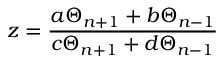<formula> <loc_0><loc_0><loc_500><loc_500>z = \frac { a \Theta _ { n + 1 } + b \Theta _ { n - 1 } } { c \Theta _ { n + 1 } + d \Theta _ { n - 1 } }</formula> 